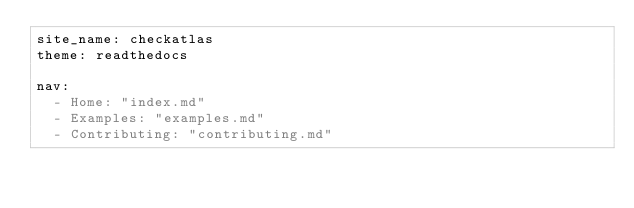Convert code to text. <code><loc_0><loc_0><loc_500><loc_500><_YAML_>site_name: checkatlas
theme: readthedocs

nav:
  - Home: "index.md"
  - Examples: "examples.md"
  - Contributing: "contributing.md"</code> 